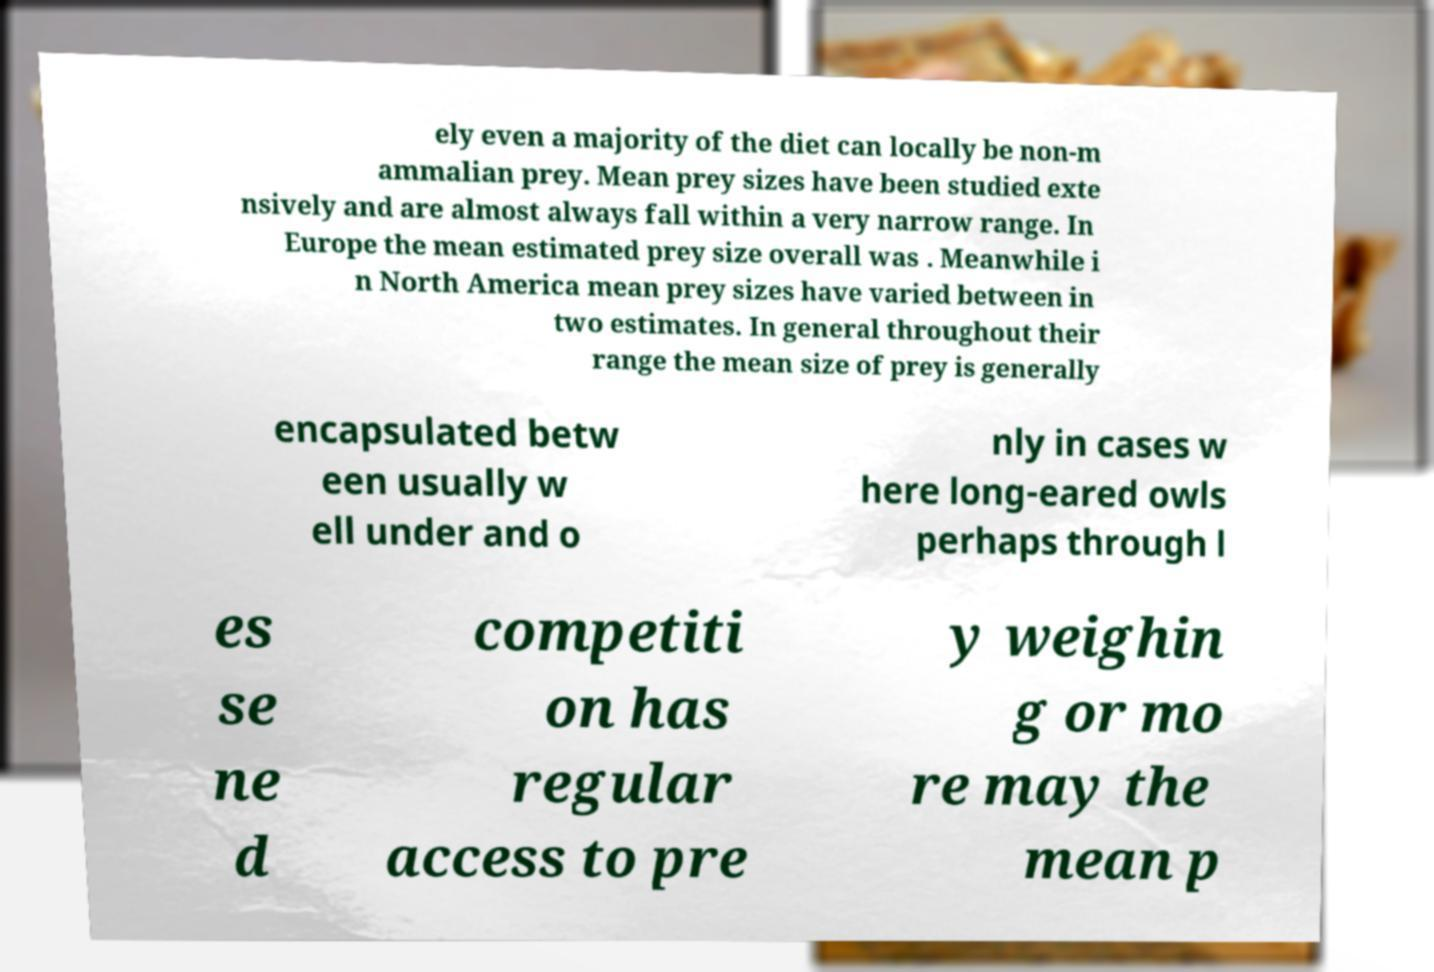Could you extract and type out the text from this image? ely even a majority of the diet can locally be non-m ammalian prey. Mean prey sizes have been studied exte nsively and are almost always fall within a very narrow range. In Europe the mean estimated prey size overall was . Meanwhile i n North America mean prey sizes have varied between in two estimates. In general throughout their range the mean size of prey is generally encapsulated betw een usually w ell under and o nly in cases w here long-eared owls perhaps through l es se ne d competiti on has regular access to pre y weighin g or mo re may the mean p 